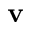Convert formula to latex. <formula><loc_0><loc_0><loc_500><loc_500>v</formula> 